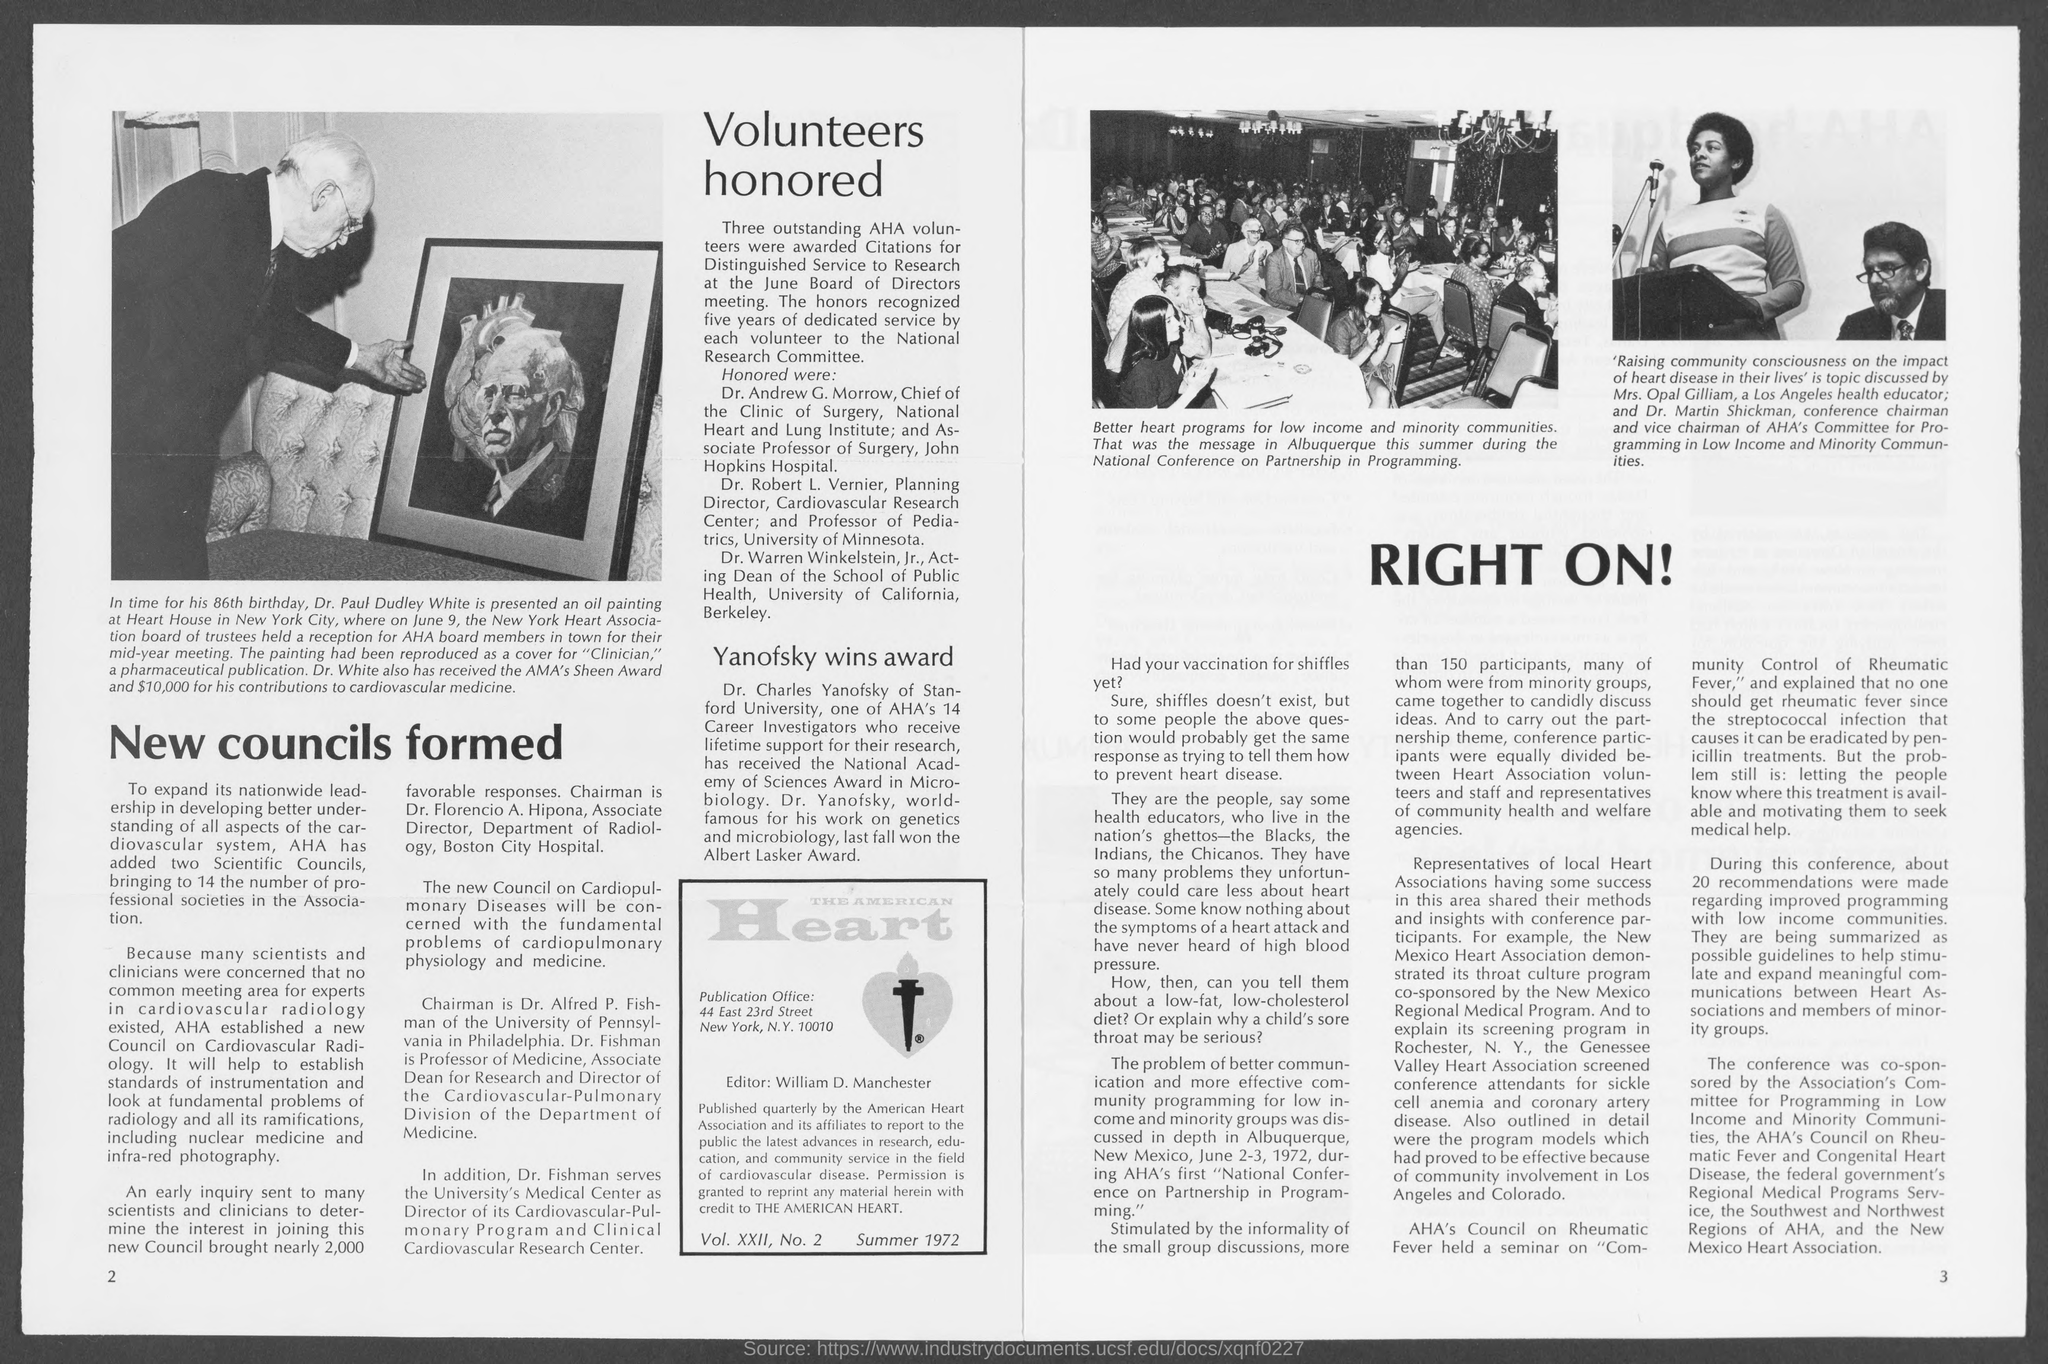Who is the editor of the american heart?
Your answer should be very brief. William d. manchester. In which city is publication office at ?
Offer a very short reply. New york. What is the number at bottom-left corner of the page ?
Make the answer very short. 2. What is the number at bottom-right corner of the page ?
Make the answer very short. 3. 